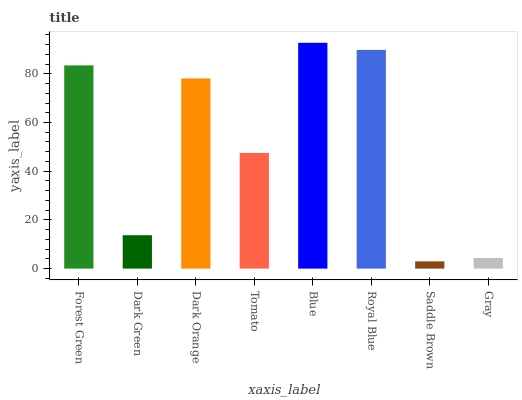Is Saddle Brown the minimum?
Answer yes or no. Yes. Is Blue the maximum?
Answer yes or no. Yes. Is Dark Green the minimum?
Answer yes or no. No. Is Dark Green the maximum?
Answer yes or no. No. Is Forest Green greater than Dark Green?
Answer yes or no. Yes. Is Dark Green less than Forest Green?
Answer yes or no. Yes. Is Dark Green greater than Forest Green?
Answer yes or no. No. Is Forest Green less than Dark Green?
Answer yes or no. No. Is Dark Orange the high median?
Answer yes or no. Yes. Is Tomato the low median?
Answer yes or no. Yes. Is Royal Blue the high median?
Answer yes or no. No. Is Dark Orange the low median?
Answer yes or no. No. 